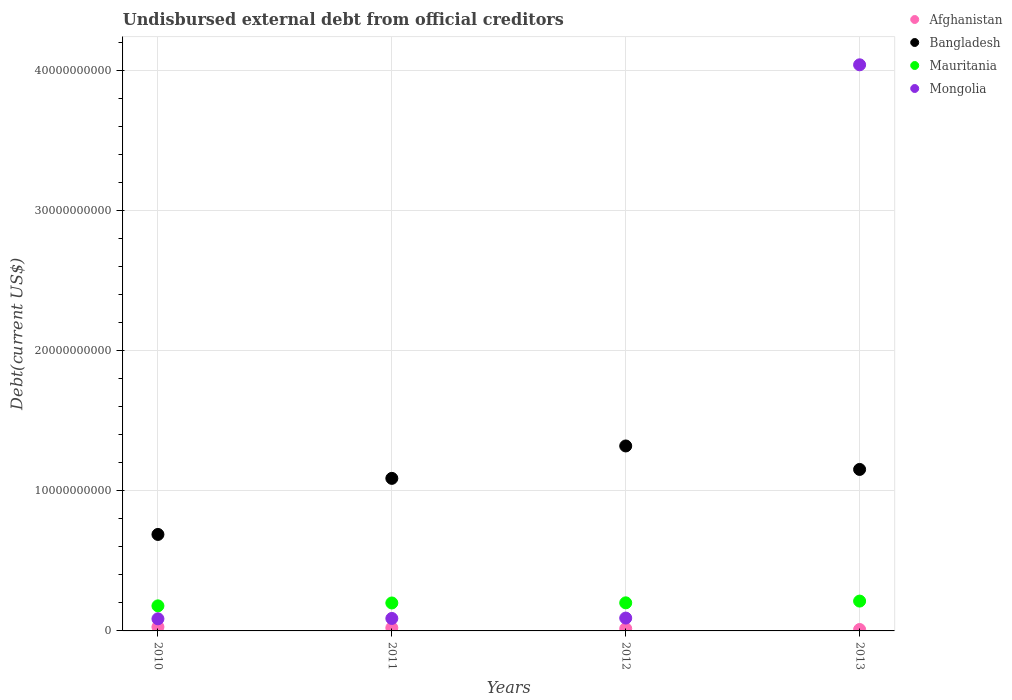Is the number of dotlines equal to the number of legend labels?
Ensure brevity in your answer.  Yes. What is the total debt in Bangladesh in 2011?
Provide a short and direct response. 1.09e+1. Across all years, what is the maximum total debt in Bangladesh?
Keep it short and to the point. 1.32e+1. Across all years, what is the minimum total debt in Mongolia?
Your response must be concise. 8.64e+08. In which year was the total debt in Mongolia maximum?
Keep it short and to the point. 2013. What is the total total debt in Afghanistan in the graph?
Ensure brevity in your answer.  7.67e+08. What is the difference between the total debt in Mongolia in 2010 and that in 2012?
Provide a short and direct response. -5.34e+07. What is the difference between the total debt in Afghanistan in 2011 and the total debt in Bangladesh in 2010?
Provide a short and direct response. -6.66e+09. What is the average total debt in Afghanistan per year?
Give a very brief answer. 1.92e+08. In the year 2013, what is the difference between the total debt in Mongolia and total debt in Afghanistan?
Give a very brief answer. 4.03e+1. In how many years, is the total debt in Mauritania greater than 2000000000 US$?
Offer a very short reply. 2. What is the ratio of the total debt in Mongolia in 2010 to that in 2013?
Provide a succinct answer. 0.02. Is the difference between the total debt in Mongolia in 2010 and 2012 greater than the difference between the total debt in Afghanistan in 2010 and 2012?
Provide a short and direct response. No. What is the difference between the highest and the second highest total debt in Afghanistan?
Offer a very short reply. 6.44e+07. What is the difference between the highest and the lowest total debt in Afghanistan?
Offer a terse response. 1.83e+08. In how many years, is the total debt in Afghanistan greater than the average total debt in Afghanistan taken over all years?
Ensure brevity in your answer.  2. Is it the case that in every year, the sum of the total debt in Bangladesh and total debt in Mongolia  is greater than the total debt in Mauritania?
Provide a succinct answer. Yes. Does the total debt in Mauritania monotonically increase over the years?
Ensure brevity in your answer.  Yes. Is the total debt in Mauritania strictly greater than the total debt in Mongolia over the years?
Keep it short and to the point. No. How many dotlines are there?
Offer a terse response. 4. How many years are there in the graph?
Provide a succinct answer. 4. Does the graph contain any zero values?
Give a very brief answer. No. Does the graph contain grids?
Your answer should be very brief. Yes. How many legend labels are there?
Keep it short and to the point. 4. How are the legend labels stacked?
Your answer should be very brief. Vertical. What is the title of the graph?
Provide a succinct answer. Undisbursed external debt from official creditors. Does "Togo" appear as one of the legend labels in the graph?
Offer a very short reply. No. What is the label or title of the Y-axis?
Keep it short and to the point. Debt(current US$). What is the Debt(current US$) in Afghanistan in 2010?
Your answer should be very brief. 2.84e+08. What is the Debt(current US$) of Bangladesh in 2010?
Your response must be concise. 6.88e+09. What is the Debt(current US$) of Mauritania in 2010?
Your response must be concise. 1.79e+09. What is the Debt(current US$) of Mongolia in 2010?
Give a very brief answer. 8.64e+08. What is the Debt(current US$) in Afghanistan in 2011?
Make the answer very short. 2.20e+08. What is the Debt(current US$) of Bangladesh in 2011?
Ensure brevity in your answer.  1.09e+1. What is the Debt(current US$) of Mauritania in 2011?
Your response must be concise. 1.99e+09. What is the Debt(current US$) of Mongolia in 2011?
Your answer should be compact. 8.90e+08. What is the Debt(current US$) in Afghanistan in 2012?
Provide a short and direct response. 1.61e+08. What is the Debt(current US$) in Bangladesh in 2012?
Make the answer very short. 1.32e+1. What is the Debt(current US$) in Mauritania in 2012?
Your answer should be very brief. 2.00e+09. What is the Debt(current US$) in Mongolia in 2012?
Provide a short and direct response. 9.17e+08. What is the Debt(current US$) in Afghanistan in 2013?
Offer a terse response. 1.02e+08. What is the Debt(current US$) of Bangladesh in 2013?
Keep it short and to the point. 1.15e+1. What is the Debt(current US$) in Mauritania in 2013?
Provide a short and direct response. 2.13e+09. What is the Debt(current US$) of Mongolia in 2013?
Your answer should be very brief. 4.04e+1. Across all years, what is the maximum Debt(current US$) in Afghanistan?
Keep it short and to the point. 2.84e+08. Across all years, what is the maximum Debt(current US$) in Bangladesh?
Give a very brief answer. 1.32e+1. Across all years, what is the maximum Debt(current US$) in Mauritania?
Provide a short and direct response. 2.13e+09. Across all years, what is the maximum Debt(current US$) in Mongolia?
Provide a succinct answer. 4.04e+1. Across all years, what is the minimum Debt(current US$) in Afghanistan?
Keep it short and to the point. 1.02e+08. Across all years, what is the minimum Debt(current US$) in Bangladesh?
Provide a succinct answer. 6.88e+09. Across all years, what is the minimum Debt(current US$) in Mauritania?
Your response must be concise. 1.79e+09. Across all years, what is the minimum Debt(current US$) in Mongolia?
Keep it short and to the point. 8.64e+08. What is the total Debt(current US$) of Afghanistan in the graph?
Your response must be concise. 7.67e+08. What is the total Debt(current US$) of Bangladesh in the graph?
Offer a very short reply. 4.25e+1. What is the total Debt(current US$) in Mauritania in the graph?
Provide a short and direct response. 7.91e+09. What is the total Debt(current US$) in Mongolia in the graph?
Offer a terse response. 4.31e+1. What is the difference between the Debt(current US$) in Afghanistan in 2010 and that in 2011?
Provide a succinct answer. 6.44e+07. What is the difference between the Debt(current US$) in Bangladesh in 2010 and that in 2011?
Your answer should be compact. -4.00e+09. What is the difference between the Debt(current US$) of Mauritania in 2010 and that in 2011?
Offer a terse response. -2.06e+08. What is the difference between the Debt(current US$) in Mongolia in 2010 and that in 2011?
Your response must be concise. -2.63e+07. What is the difference between the Debt(current US$) in Afghanistan in 2010 and that in 2012?
Offer a terse response. 1.23e+08. What is the difference between the Debt(current US$) of Bangladesh in 2010 and that in 2012?
Keep it short and to the point. -6.31e+09. What is the difference between the Debt(current US$) in Mauritania in 2010 and that in 2012?
Your answer should be compact. -2.16e+08. What is the difference between the Debt(current US$) in Mongolia in 2010 and that in 2012?
Ensure brevity in your answer.  -5.34e+07. What is the difference between the Debt(current US$) in Afghanistan in 2010 and that in 2013?
Give a very brief answer. 1.83e+08. What is the difference between the Debt(current US$) of Bangladesh in 2010 and that in 2013?
Offer a very short reply. -4.64e+09. What is the difference between the Debt(current US$) in Mauritania in 2010 and that in 2013?
Offer a very short reply. -3.40e+08. What is the difference between the Debt(current US$) in Mongolia in 2010 and that in 2013?
Keep it short and to the point. -3.95e+1. What is the difference between the Debt(current US$) in Afghanistan in 2011 and that in 2012?
Ensure brevity in your answer.  5.87e+07. What is the difference between the Debt(current US$) in Bangladesh in 2011 and that in 2012?
Provide a succinct answer. -2.31e+09. What is the difference between the Debt(current US$) in Mauritania in 2011 and that in 2012?
Your response must be concise. -9.65e+06. What is the difference between the Debt(current US$) in Mongolia in 2011 and that in 2012?
Make the answer very short. -2.71e+07. What is the difference between the Debt(current US$) in Afghanistan in 2011 and that in 2013?
Offer a terse response. 1.18e+08. What is the difference between the Debt(current US$) in Bangladesh in 2011 and that in 2013?
Your answer should be compact. -6.38e+08. What is the difference between the Debt(current US$) of Mauritania in 2011 and that in 2013?
Your answer should be compact. -1.34e+08. What is the difference between the Debt(current US$) in Mongolia in 2011 and that in 2013?
Give a very brief answer. -3.95e+1. What is the difference between the Debt(current US$) in Afghanistan in 2012 and that in 2013?
Your answer should be very brief. 5.97e+07. What is the difference between the Debt(current US$) in Bangladesh in 2012 and that in 2013?
Make the answer very short. 1.67e+09. What is the difference between the Debt(current US$) of Mauritania in 2012 and that in 2013?
Your response must be concise. -1.25e+08. What is the difference between the Debt(current US$) in Mongolia in 2012 and that in 2013?
Provide a succinct answer. -3.95e+1. What is the difference between the Debt(current US$) of Afghanistan in 2010 and the Debt(current US$) of Bangladesh in 2011?
Provide a succinct answer. -1.06e+1. What is the difference between the Debt(current US$) of Afghanistan in 2010 and the Debt(current US$) of Mauritania in 2011?
Provide a short and direct response. -1.71e+09. What is the difference between the Debt(current US$) in Afghanistan in 2010 and the Debt(current US$) in Mongolia in 2011?
Keep it short and to the point. -6.05e+08. What is the difference between the Debt(current US$) of Bangladesh in 2010 and the Debt(current US$) of Mauritania in 2011?
Your response must be concise. 4.89e+09. What is the difference between the Debt(current US$) of Bangladesh in 2010 and the Debt(current US$) of Mongolia in 2011?
Provide a succinct answer. 5.99e+09. What is the difference between the Debt(current US$) of Mauritania in 2010 and the Debt(current US$) of Mongolia in 2011?
Your response must be concise. 8.98e+08. What is the difference between the Debt(current US$) in Afghanistan in 2010 and the Debt(current US$) in Bangladesh in 2012?
Offer a very short reply. -1.29e+1. What is the difference between the Debt(current US$) in Afghanistan in 2010 and the Debt(current US$) in Mauritania in 2012?
Your answer should be very brief. -1.72e+09. What is the difference between the Debt(current US$) in Afghanistan in 2010 and the Debt(current US$) in Mongolia in 2012?
Your answer should be very brief. -6.33e+08. What is the difference between the Debt(current US$) of Bangladesh in 2010 and the Debt(current US$) of Mauritania in 2012?
Ensure brevity in your answer.  4.88e+09. What is the difference between the Debt(current US$) in Bangladesh in 2010 and the Debt(current US$) in Mongolia in 2012?
Provide a succinct answer. 5.97e+09. What is the difference between the Debt(current US$) of Mauritania in 2010 and the Debt(current US$) of Mongolia in 2012?
Provide a succinct answer. 8.71e+08. What is the difference between the Debt(current US$) of Afghanistan in 2010 and the Debt(current US$) of Bangladesh in 2013?
Give a very brief answer. -1.12e+1. What is the difference between the Debt(current US$) of Afghanistan in 2010 and the Debt(current US$) of Mauritania in 2013?
Your response must be concise. -1.84e+09. What is the difference between the Debt(current US$) of Afghanistan in 2010 and the Debt(current US$) of Mongolia in 2013?
Give a very brief answer. -4.01e+1. What is the difference between the Debt(current US$) in Bangladesh in 2010 and the Debt(current US$) in Mauritania in 2013?
Provide a succinct answer. 4.76e+09. What is the difference between the Debt(current US$) in Bangladesh in 2010 and the Debt(current US$) in Mongolia in 2013?
Provide a succinct answer. -3.35e+1. What is the difference between the Debt(current US$) of Mauritania in 2010 and the Debt(current US$) of Mongolia in 2013?
Give a very brief answer. -3.86e+1. What is the difference between the Debt(current US$) in Afghanistan in 2011 and the Debt(current US$) in Bangladesh in 2012?
Your answer should be compact. -1.30e+1. What is the difference between the Debt(current US$) of Afghanistan in 2011 and the Debt(current US$) of Mauritania in 2012?
Your answer should be very brief. -1.78e+09. What is the difference between the Debt(current US$) of Afghanistan in 2011 and the Debt(current US$) of Mongolia in 2012?
Your answer should be compact. -6.97e+08. What is the difference between the Debt(current US$) of Bangladesh in 2011 and the Debt(current US$) of Mauritania in 2012?
Your answer should be compact. 8.88e+09. What is the difference between the Debt(current US$) of Bangladesh in 2011 and the Debt(current US$) of Mongolia in 2012?
Keep it short and to the point. 9.97e+09. What is the difference between the Debt(current US$) in Mauritania in 2011 and the Debt(current US$) in Mongolia in 2012?
Make the answer very short. 1.08e+09. What is the difference between the Debt(current US$) of Afghanistan in 2011 and the Debt(current US$) of Bangladesh in 2013?
Your response must be concise. -1.13e+1. What is the difference between the Debt(current US$) of Afghanistan in 2011 and the Debt(current US$) of Mauritania in 2013?
Keep it short and to the point. -1.91e+09. What is the difference between the Debt(current US$) of Afghanistan in 2011 and the Debt(current US$) of Mongolia in 2013?
Your answer should be compact. -4.02e+1. What is the difference between the Debt(current US$) of Bangladesh in 2011 and the Debt(current US$) of Mauritania in 2013?
Ensure brevity in your answer.  8.76e+09. What is the difference between the Debt(current US$) of Bangladesh in 2011 and the Debt(current US$) of Mongolia in 2013?
Offer a very short reply. -2.95e+1. What is the difference between the Debt(current US$) of Mauritania in 2011 and the Debt(current US$) of Mongolia in 2013?
Give a very brief answer. -3.84e+1. What is the difference between the Debt(current US$) of Afghanistan in 2012 and the Debt(current US$) of Bangladesh in 2013?
Make the answer very short. -1.14e+1. What is the difference between the Debt(current US$) in Afghanistan in 2012 and the Debt(current US$) in Mauritania in 2013?
Make the answer very short. -1.97e+09. What is the difference between the Debt(current US$) in Afghanistan in 2012 and the Debt(current US$) in Mongolia in 2013?
Provide a succinct answer. -4.02e+1. What is the difference between the Debt(current US$) in Bangladesh in 2012 and the Debt(current US$) in Mauritania in 2013?
Offer a terse response. 1.11e+1. What is the difference between the Debt(current US$) in Bangladesh in 2012 and the Debt(current US$) in Mongolia in 2013?
Ensure brevity in your answer.  -2.72e+1. What is the difference between the Debt(current US$) of Mauritania in 2012 and the Debt(current US$) of Mongolia in 2013?
Provide a short and direct response. -3.84e+1. What is the average Debt(current US$) of Afghanistan per year?
Provide a succinct answer. 1.92e+08. What is the average Debt(current US$) of Bangladesh per year?
Offer a terse response. 1.06e+1. What is the average Debt(current US$) in Mauritania per year?
Offer a very short reply. 1.98e+09. What is the average Debt(current US$) of Mongolia per year?
Ensure brevity in your answer.  1.08e+1. In the year 2010, what is the difference between the Debt(current US$) of Afghanistan and Debt(current US$) of Bangladesh?
Ensure brevity in your answer.  -6.60e+09. In the year 2010, what is the difference between the Debt(current US$) of Afghanistan and Debt(current US$) of Mauritania?
Your answer should be compact. -1.50e+09. In the year 2010, what is the difference between the Debt(current US$) in Afghanistan and Debt(current US$) in Mongolia?
Provide a short and direct response. -5.79e+08. In the year 2010, what is the difference between the Debt(current US$) in Bangladesh and Debt(current US$) in Mauritania?
Your response must be concise. 5.10e+09. In the year 2010, what is the difference between the Debt(current US$) of Bangladesh and Debt(current US$) of Mongolia?
Keep it short and to the point. 6.02e+09. In the year 2010, what is the difference between the Debt(current US$) of Mauritania and Debt(current US$) of Mongolia?
Your response must be concise. 9.24e+08. In the year 2011, what is the difference between the Debt(current US$) in Afghanistan and Debt(current US$) in Bangladesh?
Your response must be concise. -1.07e+1. In the year 2011, what is the difference between the Debt(current US$) of Afghanistan and Debt(current US$) of Mauritania?
Your response must be concise. -1.77e+09. In the year 2011, what is the difference between the Debt(current US$) of Afghanistan and Debt(current US$) of Mongolia?
Ensure brevity in your answer.  -6.70e+08. In the year 2011, what is the difference between the Debt(current US$) in Bangladesh and Debt(current US$) in Mauritania?
Give a very brief answer. 8.89e+09. In the year 2011, what is the difference between the Debt(current US$) of Bangladesh and Debt(current US$) of Mongolia?
Your response must be concise. 1.00e+1. In the year 2011, what is the difference between the Debt(current US$) in Mauritania and Debt(current US$) in Mongolia?
Make the answer very short. 1.10e+09. In the year 2012, what is the difference between the Debt(current US$) of Afghanistan and Debt(current US$) of Bangladesh?
Offer a terse response. -1.30e+1. In the year 2012, what is the difference between the Debt(current US$) of Afghanistan and Debt(current US$) of Mauritania?
Ensure brevity in your answer.  -1.84e+09. In the year 2012, what is the difference between the Debt(current US$) in Afghanistan and Debt(current US$) in Mongolia?
Your answer should be very brief. -7.56e+08. In the year 2012, what is the difference between the Debt(current US$) in Bangladesh and Debt(current US$) in Mauritania?
Your answer should be very brief. 1.12e+1. In the year 2012, what is the difference between the Debt(current US$) of Bangladesh and Debt(current US$) of Mongolia?
Make the answer very short. 1.23e+1. In the year 2012, what is the difference between the Debt(current US$) in Mauritania and Debt(current US$) in Mongolia?
Offer a very short reply. 1.09e+09. In the year 2013, what is the difference between the Debt(current US$) of Afghanistan and Debt(current US$) of Bangladesh?
Offer a terse response. -1.14e+1. In the year 2013, what is the difference between the Debt(current US$) in Afghanistan and Debt(current US$) in Mauritania?
Offer a very short reply. -2.03e+09. In the year 2013, what is the difference between the Debt(current US$) in Afghanistan and Debt(current US$) in Mongolia?
Provide a succinct answer. -4.03e+1. In the year 2013, what is the difference between the Debt(current US$) of Bangladesh and Debt(current US$) of Mauritania?
Give a very brief answer. 9.40e+09. In the year 2013, what is the difference between the Debt(current US$) of Bangladesh and Debt(current US$) of Mongolia?
Offer a terse response. -2.89e+1. In the year 2013, what is the difference between the Debt(current US$) of Mauritania and Debt(current US$) of Mongolia?
Your answer should be very brief. -3.83e+1. What is the ratio of the Debt(current US$) of Afghanistan in 2010 to that in 2011?
Provide a short and direct response. 1.29. What is the ratio of the Debt(current US$) of Bangladesh in 2010 to that in 2011?
Keep it short and to the point. 0.63. What is the ratio of the Debt(current US$) of Mauritania in 2010 to that in 2011?
Provide a short and direct response. 0.9. What is the ratio of the Debt(current US$) in Mongolia in 2010 to that in 2011?
Your answer should be compact. 0.97. What is the ratio of the Debt(current US$) of Afghanistan in 2010 to that in 2012?
Provide a short and direct response. 1.76. What is the ratio of the Debt(current US$) of Bangladesh in 2010 to that in 2012?
Ensure brevity in your answer.  0.52. What is the ratio of the Debt(current US$) of Mauritania in 2010 to that in 2012?
Your response must be concise. 0.89. What is the ratio of the Debt(current US$) in Mongolia in 2010 to that in 2012?
Your answer should be very brief. 0.94. What is the ratio of the Debt(current US$) of Afghanistan in 2010 to that in 2013?
Keep it short and to the point. 2.8. What is the ratio of the Debt(current US$) in Bangladesh in 2010 to that in 2013?
Ensure brevity in your answer.  0.6. What is the ratio of the Debt(current US$) in Mauritania in 2010 to that in 2013?
Your answer should be compact. 0.84. What is the ratio of the Debt(current US$) in Mongolia in 2010 to that in 2013?
Offer a very short reply. 0.02. What is the ratio of the Debt(current US$) in Afghanistan in 2011 to that in 2012?
Give a very brief answer. 1.36. What is the ratio of the Debt(current US$) in Bangladesh in 2011 to that in 2012?
Ensure brevity in your answer.  0.82. What is the ratio of the Debt(current US$) in Mauritania in 2011 to that in 2012?
Make the answer very short. 1. What is the ratio of the Debt(current US$) of Mongolia in 2011 to that in 2012?
Your answer should be very brief. 0.97. What is the ratio of the Debt(current US$) of Afghanistan in 2011 to that in 2013?
Provide a short and direct response. 2.17. What is the ratio of the Debt(current US$) of Bangladesh in 2011 to that in 2013?
Give a very brief answer. 0.94. What is the ratio of the Debt(current US$) in Mauritania in 2011 to that in 2013?
Your response must be concise. 0.94. What is the ratio of the Debt(current US$) of Mongolia in 2011 to that in 2013?
Provide a short and direct response. 0.02. What is the ratio of the Debt(current US$) of Afghanistan in 2012 to that in 2013?
Provide a succinct answer. 1.59. What is the ratio of the Debt(current US$) in Bangladesh in 2012 to that in 2013?
Your response must be concise. 1.15. What is the ratio of the Debt(current US$) in Mauritania in 2012 to that in 2013?
Ensure brevity in your answer.  0.94. What is the ratio of the Debt(current US$) in Mongolia in 2012 to that in 2013?
Provide a short and direct response. 0.02. What is the difference between the highest and the second highest Debt(current US$) of Afghanistan?
Provide a short and direct response. 6.44e+07. What is the difference between the highest and the second highest Debt(current US$) of Bangladesh?
Give a very brief answer. 1.67e+09. What is the difference between the highest and the second highest Debt(current US$) in Mauritania?
Offer a very short reply. 1.25e+08. What is the difference between the highest and the second highest Debt(current US$) in Mongolia?
Your answer should be compact. 3.95e+1. What is the difference between the highest and the lowest Debt(current US$) in Afghanistan?
Your answer should be compact. 1.83e+08. What is the difference between the highest and the lowest Debt(current US$) of Bangladesh?
Give a very brief answer. 6.31e+09. What is the difference between the highest and the lowest Debt(current US$) of Mauritania?
Give a very brief answer. 3.40e+08. What is the difference between the highest and the lowest Debt(current US$) of Mongolia?
Ensure brevity in your answer.  3.95e+1. 